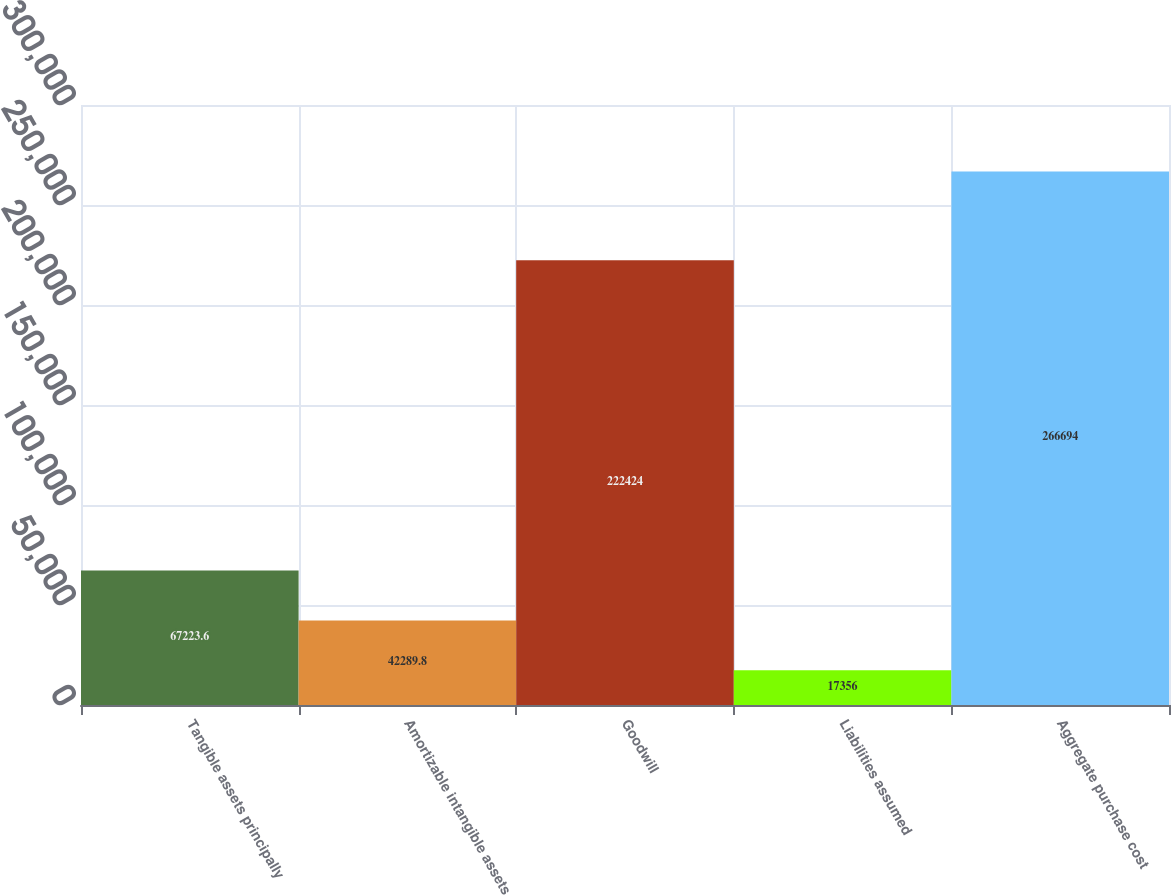<chart> <loc_0><loc_0><loc_500><loc_500><bar_chart><fcel>Tangible assets principally<fcel>Amortizable intangible assets<fcel>Goodwill<fcel>Liabilities assumed<fcel>Aggregate purchase cost<nl><fcel>67223.6<fcel>42289.8<fcel>222424<fcel>17356<fcel>266694<nl></chart> 